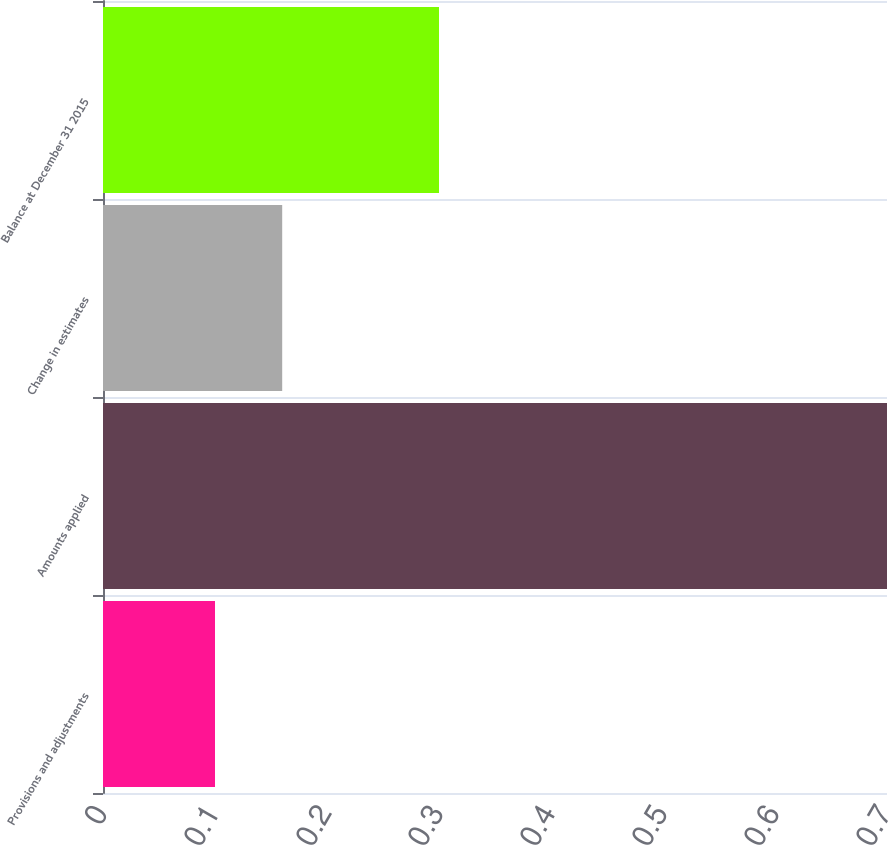Convert chart. <chart><loc_0><loc_0><loc_500><loc_500><bar_chart><fcel>Provisions and adjustments<fcel>Amounts applied<fcel>Change in estimates<fcel>Balance at December 31 2015<nl><fcel>0.1<fcel>0.7<fcel>0.16<fcel>0.3<nl></chart> 